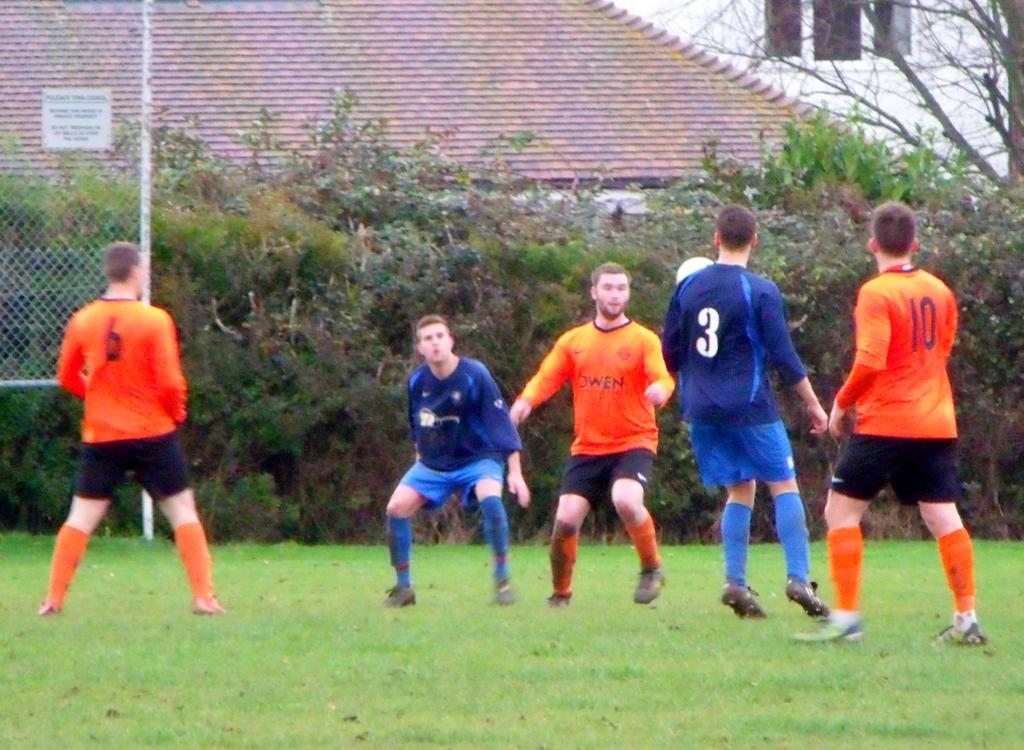<image>
Relay a brief, clear account of the picture shown. People are playing soccer and the backs of players 6, 3, and 10 are visible. 